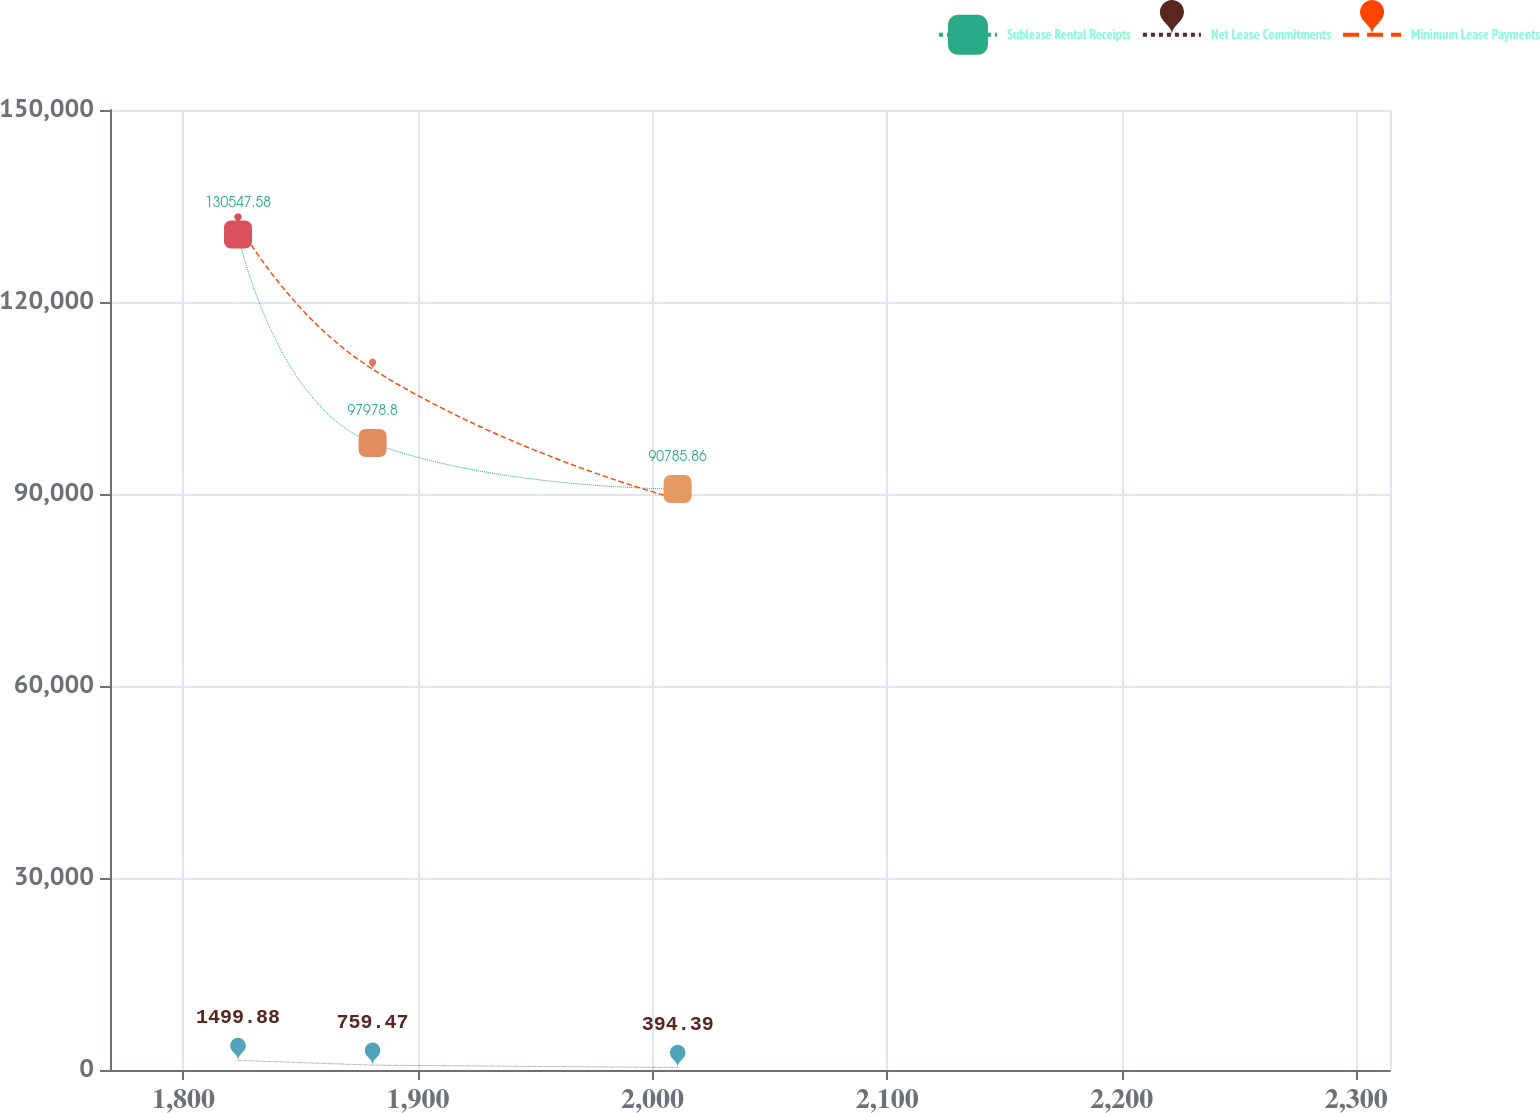<chart> <loc_0><loc_0><loc_500><loc_500><line_chart><ecel><fcel>Sublease Rental Receipts<fcel>Net Lease Commitments<fcel>Minimum Lease Payments<nl><fcel>1823.27<fcel>130548<fcel>1499.88<fcel>132224<nl><fcel>1880.65<fcel>97978.8<fcel>759.47<fcel>109510<nl><fcel>2010.69<fcel>90785.9<fcel>394.39<fcel>89220.7<nl><fcel>2315.14<fcel>74291.4<fcel>256.2<fcel>70852.3<nl><fcel>2368.93<fcel>68040.8<fcel>118.01<fcel>60343.4<nl></chart> 